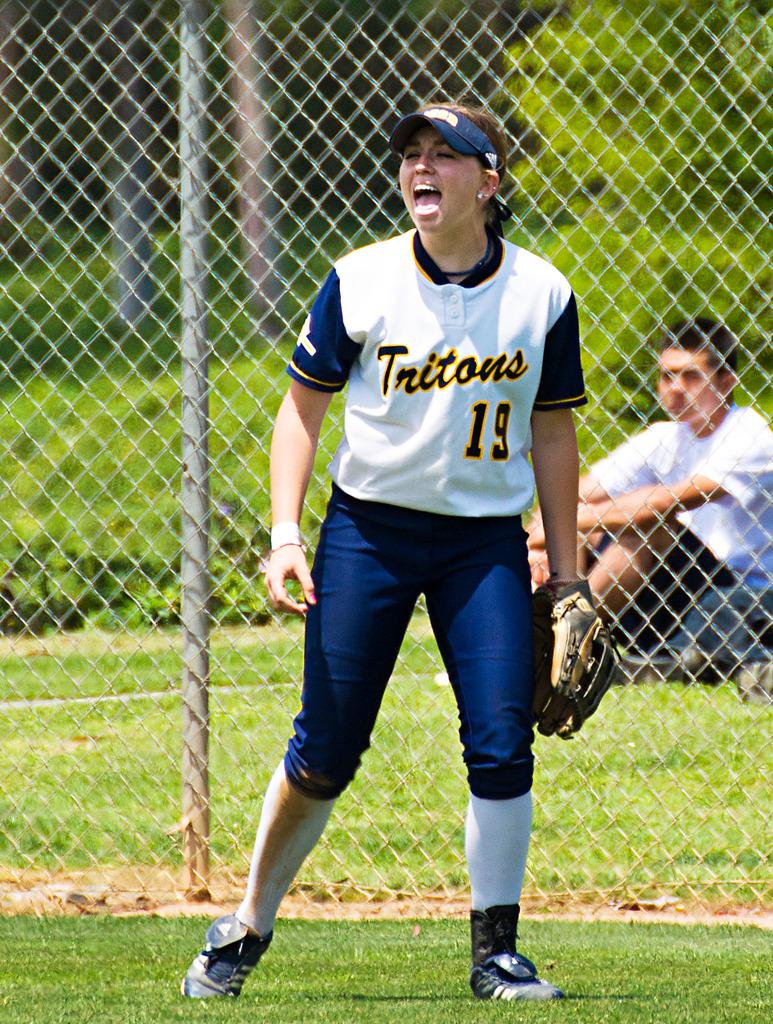What is the mascot of the team she plays for?
Keep it short and to the point. Tritons. What is the jersey number she is wearing?
Your answer should be very brief. 19. 